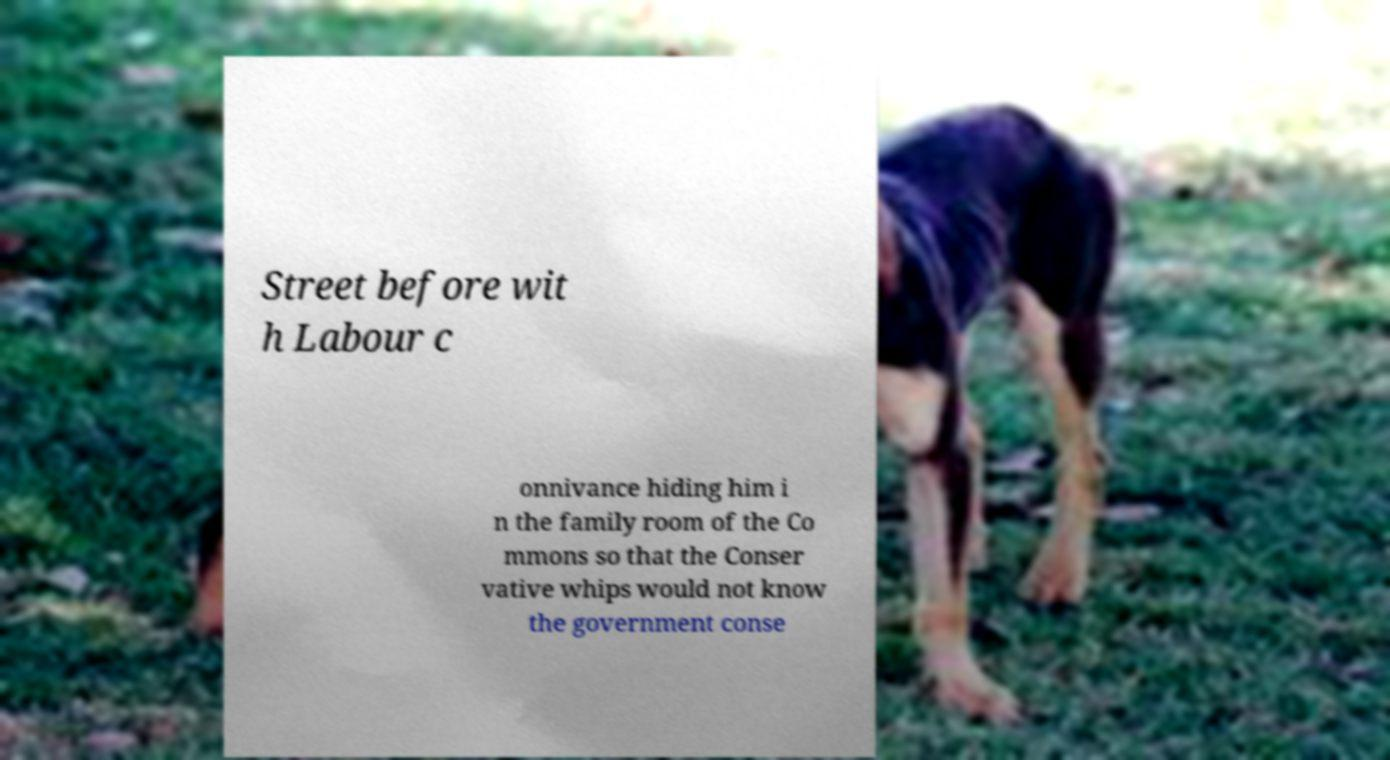What messages or text are displayed in this image? I need them in a readable, typed format. Street before wit h Labour c onnivance hiding him i n the family room of the Co mmons so that the Conser vative whips would not know the government conse 